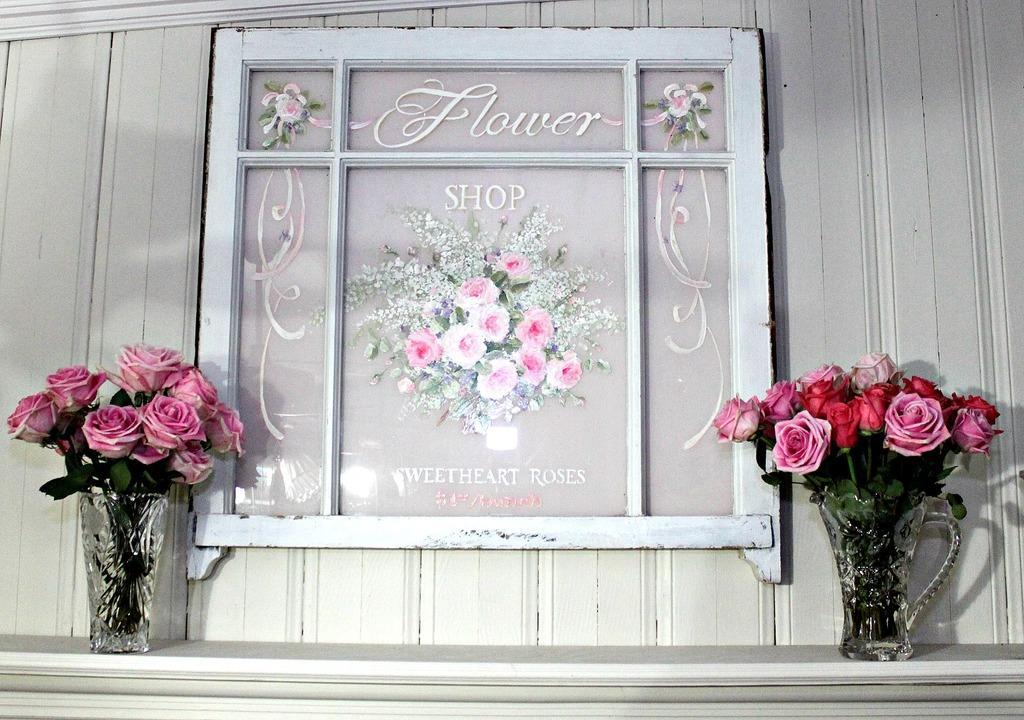Could you give a brief overview of what you see in this image? In this image there is flower vase, there are rose flowers, there is a photo frame, there is text on the photo frame, at the background of the image there is a wall. 